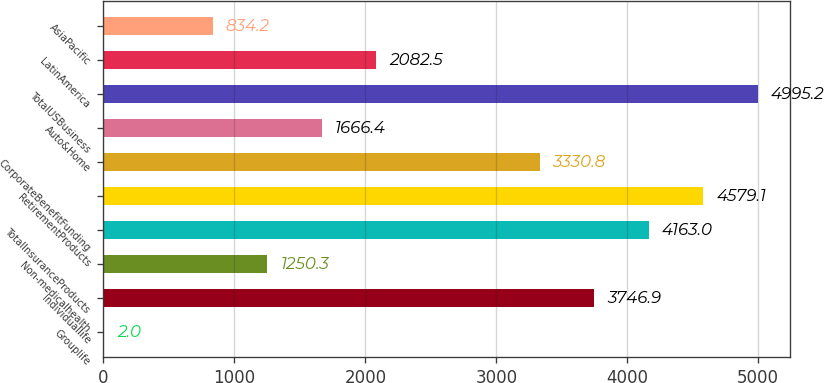<chart> <loc_0><loc_0><loc_500><loc_500><bar_chart><fcel>Grouplife<fcel>Individuallife<fcel>Non-medicalhealth<fcel>TotalInsuranceProducts<fcel>RetirementProducts<fcel>CorporateBenefitFunding<fcel>Auto&Home<fcel>TotalUSBusiness<fcel>LatinAmerica<fcel>AsiaPacific<nl><fcel>2<fcel>3746.9<fcel>1250.3<fcel>4163<fcel>4579.1<fcel>3330.8<fcel>1666.4<fcel>4995.2<fcel>2082.5<fcel>834.2<nl></chart> 